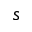<formula> <loc_0><loc_0><loc_500><loc_500>s</formula> 